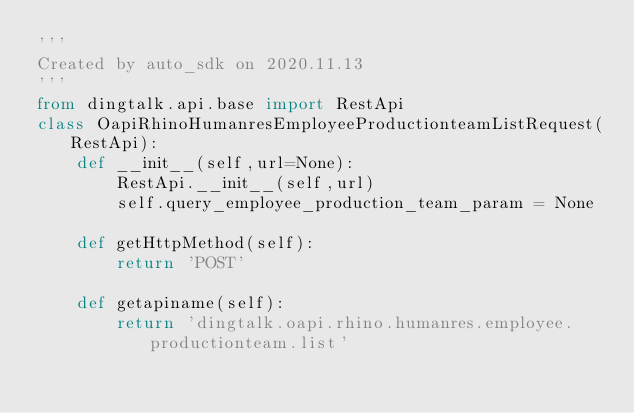Convert code to text. <code><loc_0><loc_0><loc_500><loc_500><_Python_>'''
Created by auto_sdk on 2020.11.13
'''
from dingtalk.api.base import RestApi
class OapiRhinoHumanresEmployeeProductionteamListRequest(RestApi):
	def __init__(self,url=None):
		RestApi.__init__(self,url)
		self.query_employee_production_team_param = None

	def getHttpMethod(self):
		return 'POST'

	def getapiname(self):
		return 'dingtalk.oapi.rhino.humanres.employee.productionteam.list'
</code> 